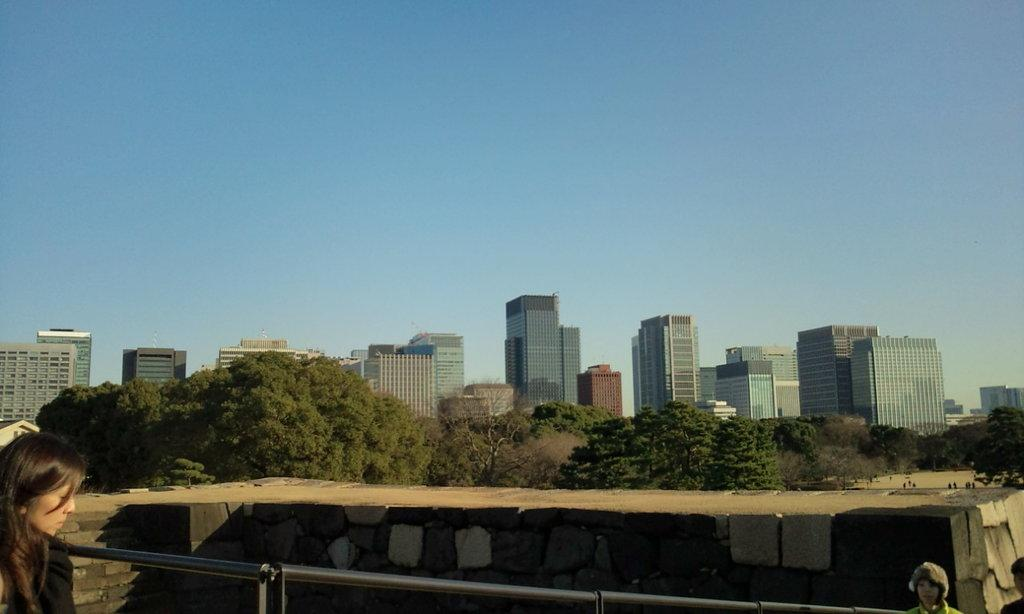Who or what can be seen in the image? There are people in the image. What is present near the people? There is railing in the image. What type of natural elements are visible in the image? There are trees in the image. What can be seen in the distance in the image? There are buildings in the background of the image. Where is the chair located in the image? There is no chair present in the image. What type of coat is being worn by the trees in the image? Trees do not wear coats; they are natural elements and do not have clothing. 